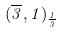Convert formula to latex. <formula><loc_0><loc_0><loc_500><loc_500>( \overline { 3 } , 1 ) _ { \frac { 1 } { 3 } }</formula> 